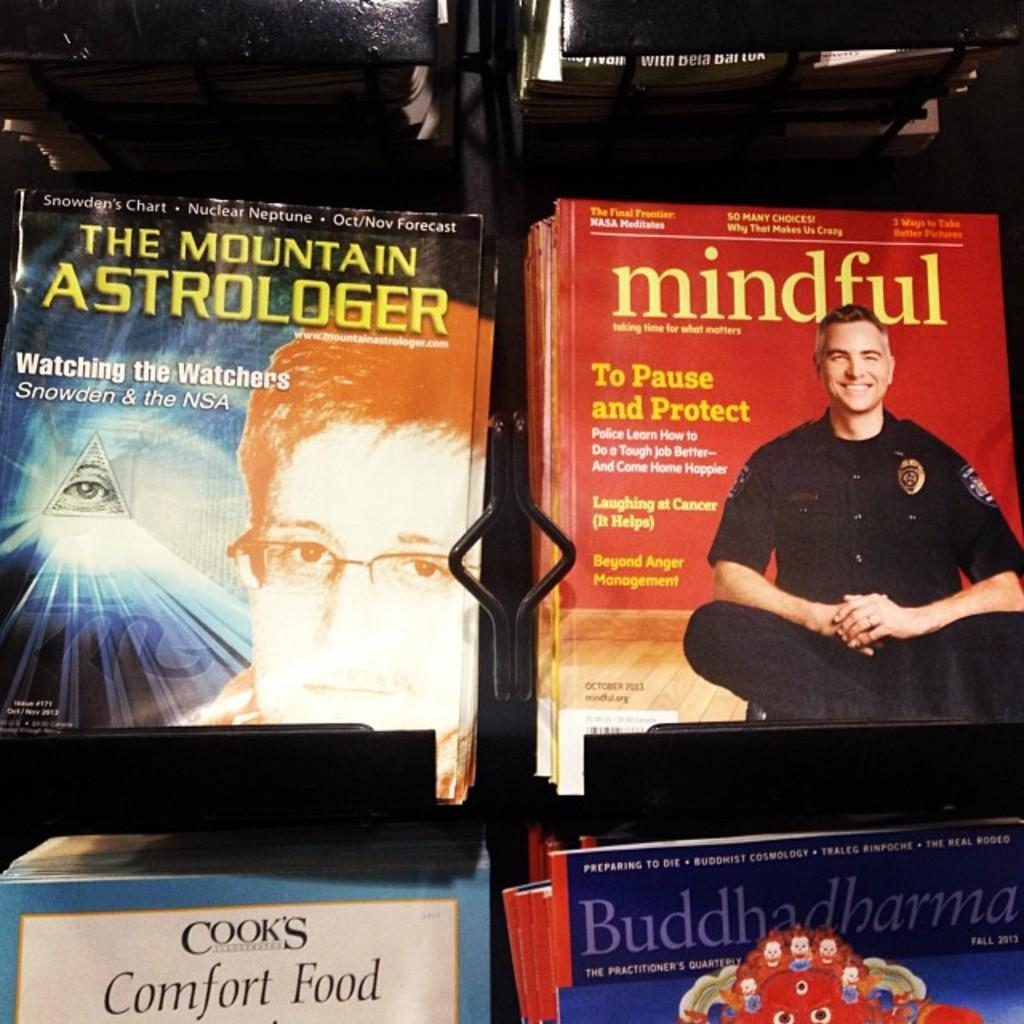<image>
Relay a brief, clear account of the picture shown. several books on display like Mindful and Mountain Astrologer 